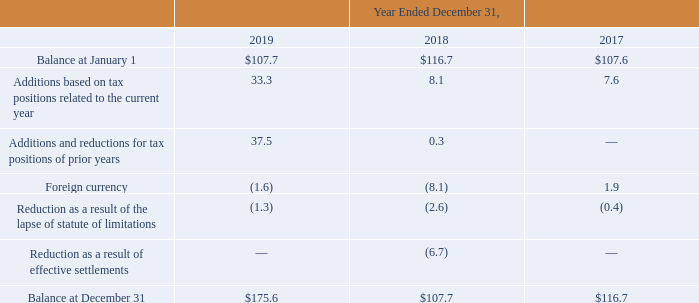AMERICAN TOWER CORPORATION AND SUBSIDIARIES NOTES TO CONSOLIDATED FINANCIAL STATEMENTS (Tabular amounts in millions, unless otherwise disclosed)
The Company expects the unrecognized tax benefits to change over the next 12 months if certain tax matters ultimately settle with the applicable taxing jurisdiction during this timeframe, or if the applicable statute of limitations lapses. The impact of the amount of such changes to previously recorded uncertain tax positions could range from zero to $53.0 million.
A reconciliation of the beginning and ending amount of unrecognized tax benefits are as follows:
During the years ended December 31, 2019, 2018 and 2017, the statute of limitations on certain unrecognized tax benefits lapsed and certain positions were effectively settled, which resulted in a decrease of $2.5 million, $9.3 million and $0.4 million, respectively, in the liability for uncertain tax benefits.
The Company recorded penalties and tax-related interest expense to the tax provision of $10.3 million, $8.0 million and $5.0 million for the years ended December 31, 2019, 2018 and 2017, respectively. In addition, due to the expiration of the statute of limitations in certain jurisdictions and certain positions that were effectively settled, the Company reduced its liability for penalties and income tax-related interest expense related to uncertain tax positions during the years ended December 31, 2019, 2018 and 2017 by $2.7 million, $16.2 million and $0.6 million, respectively.
As of December 31, 2019 and 2018, the total amount of accrued income tax-related interest and penalties included in the consolidated balance sheets were $26.6 million and $19.1 million, respectively.
The Company has filed for prior taxable years, and for its taxable year ended December 31, 2019 will file, numerous consolidated and separate income tax returns, including U.S. federal and state tax returns and foreign tax returns. The Company is subject to examination in the U.S. and various state and foreign jurisdictions for certain tax years. As a result of the Company’s ability to carryforward federal, state and foreign NOLs, the applicable tax years generally remain open to examination several years after the applicable loss carryforwards have been used or have expired. The Company regularly assesses the likelihood of additional assessments in each of the tax jurisdictions resulting from these examinations. The Company believes that adequate provisions have been made for income taxes for all periods through December 31, 2019.
Which years did the statute of limitations on certain unrecognized tax benefits lapse? 2019, 2018, 2017. Which years did the company record penalties and tax-related interest expense? 2019, 2018, 2017. What was the foreign currency in 2019?
Answer scale should be: million. (1.6). Which years was the balance at January 1 above $100 million? 2019##2018##2017
Answer: 3. Which years was the Additions based on tax positions related to the current year above $10 million? 2019
Answer: 1. What was the percentage change in the balance at December 31 between 2018 and 2019?
Answer scale should be: percent. ($175.6-$107.7)/$107.7
Answer: 63.05. 